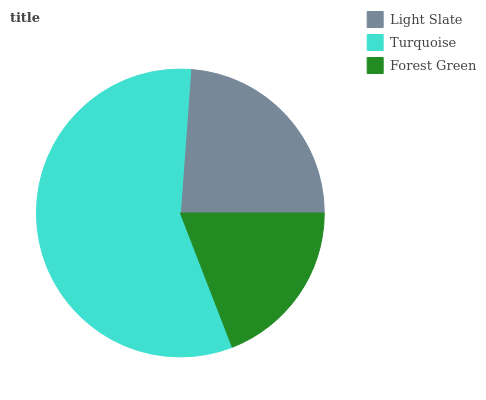Is Forest Green the minimum?
Answer yes or no. Yes. Is Turquoise the maximum?
Answer yes or no. Yes. Is Turquoise the minimum?
Answer yes or no. No. Is Forest Green the maximum?
Answer yes or no. No. Is Turquoise greater than Forest Green?
Answer yes or no. Yes. Is Forest Green less than Turquoise?
Answer yes or no. Yes. Is Forest Green greater than Turquoise?
Answer yes or no. No. Is Turquoise less than Forest Green?
Answer yes or no. No. Is Light Slate the high median?
Answer yes or no. Yes. Is Light Slate the low median?
Answer yes or no. Yes. Is Forest Green the high median?
Answer yes or no. No. Is Forest Green the low median?
Answer yes or no. No. 